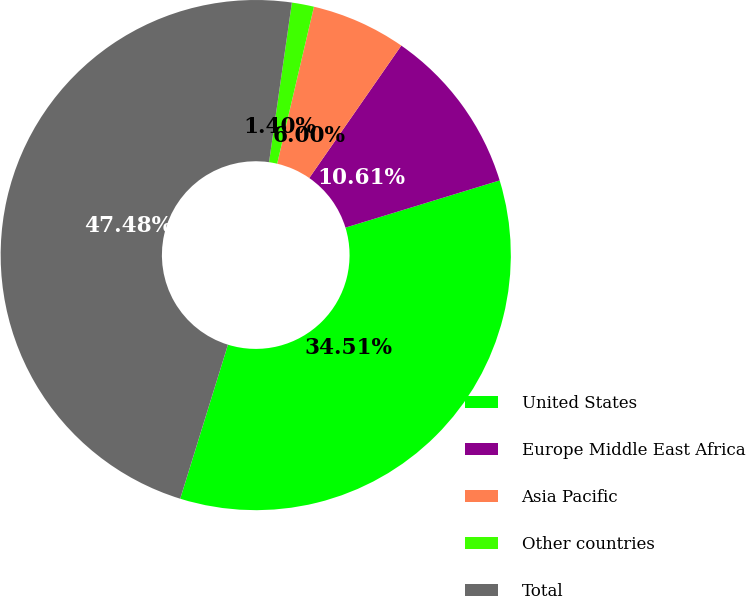Convert chart to OTSL. <chart><loc_0><loc_0><loc_500><loc_500><pie_chart><fcel>United States<fcel>Europe Middle East Africa<fcel>Asia Pacific<fcel>Other countries<fcel>Total<nl><fcel>34.51%<fcel>10.61%<fcel>6.0%<fcel>1.4%<fcel>47.48%<nl></chart> 